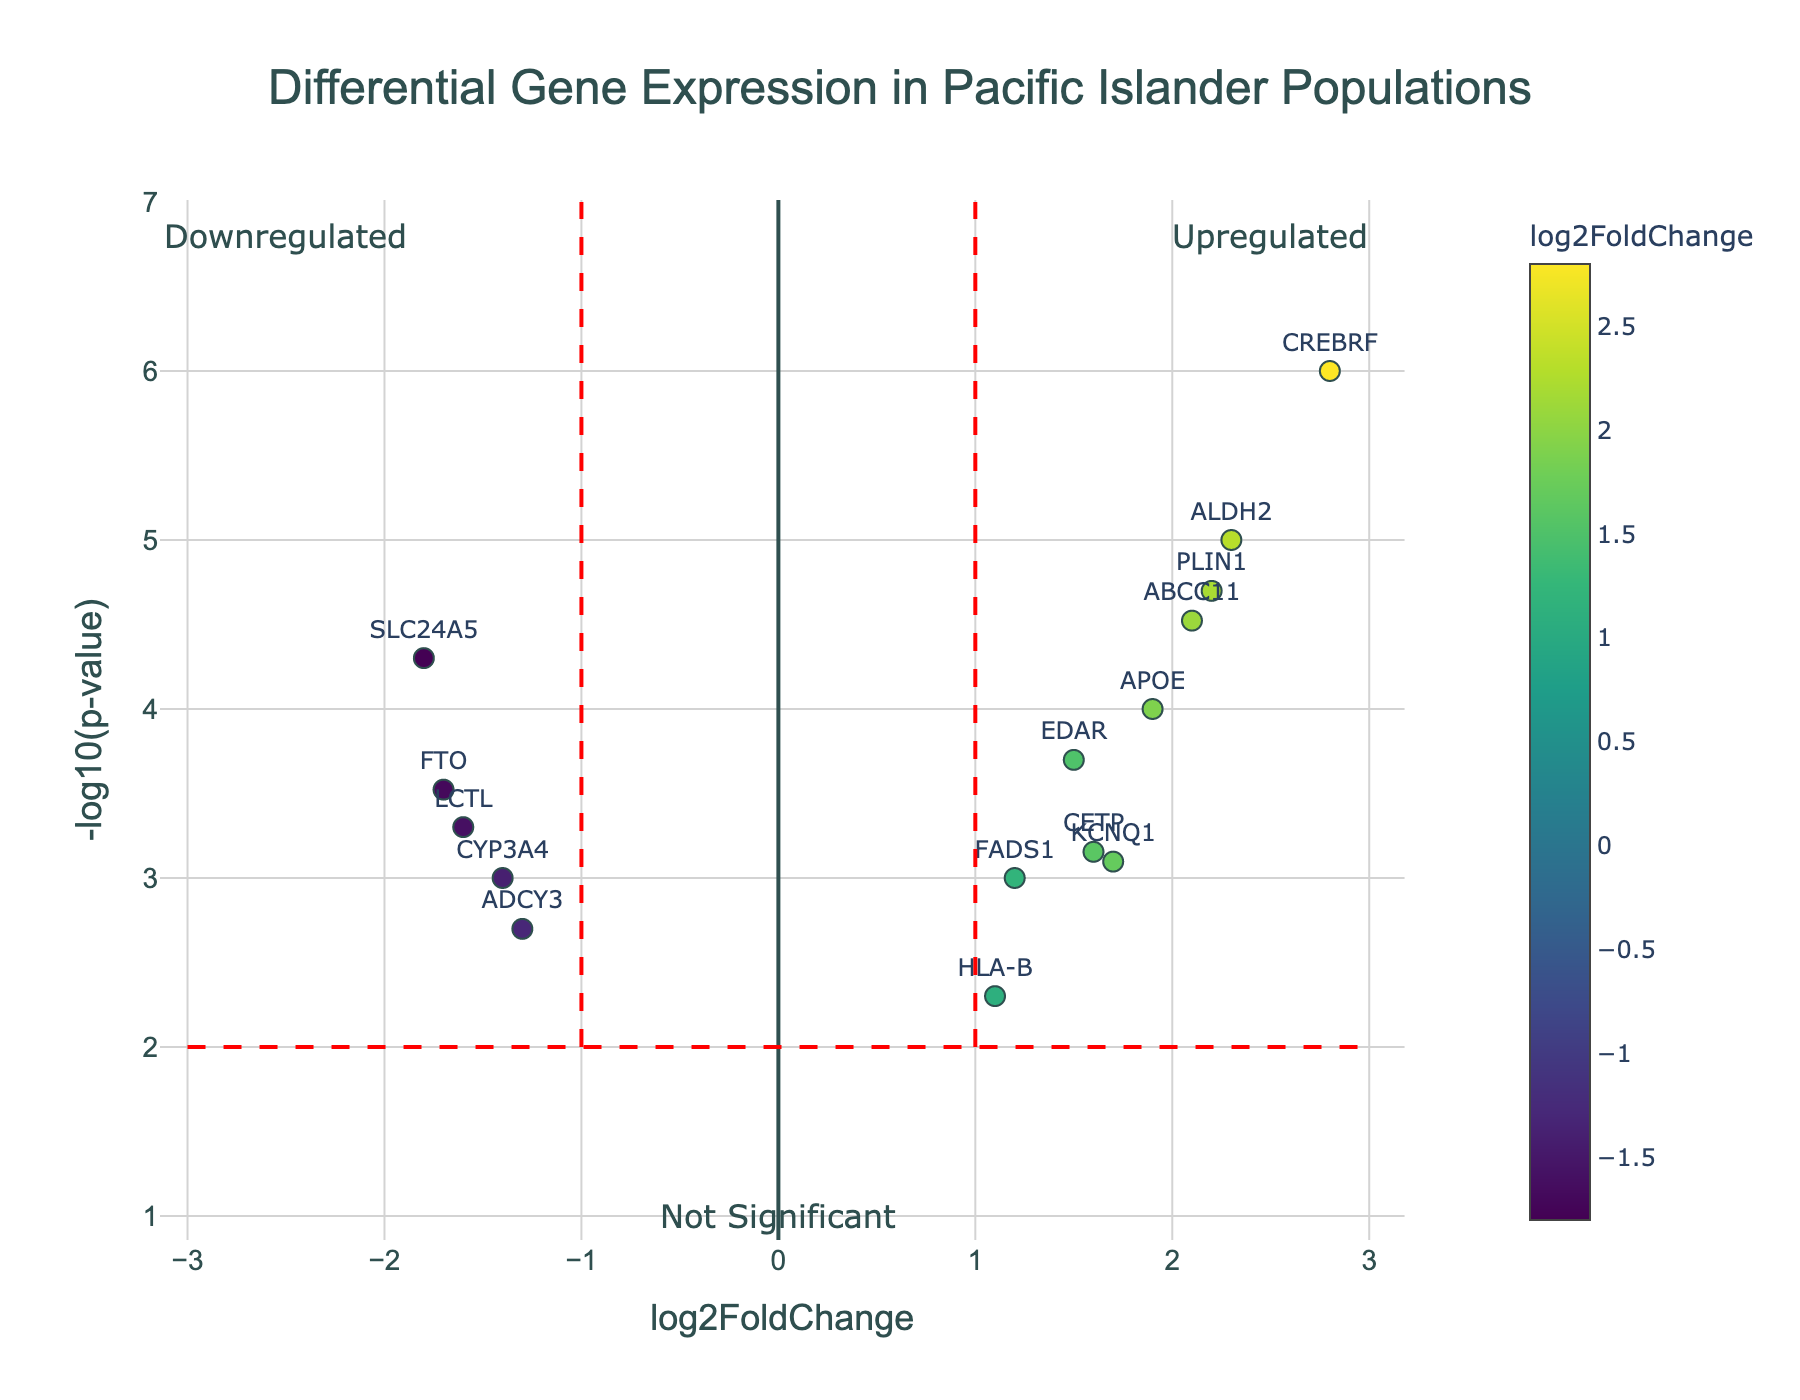what is the color gradient used to indicate in the scatter plot? The color gradient in the scatter plot is used to indicate the log2FoldChange of the genes. Darker colors represent more extreme values, while lighter colors indicate values closer to zero.
Answer: log2FoldChange What does a data point above the horizontal red dashed line represent? Any data point above the horizontal red dashed line represents a gene with a -log10(p-value) greater than 2, indicating it is statistically significant (p-value less than 0.01).
Answer: Statistically significant genes Which gene shows the highest log2FoldChange? By looking at the plot, the gene with the highest log2FoldChange is CREBRF. It is the point farthest to the right, showing a log2FoldChange of 2.8.
Answer: CREBRF What does the left-most red vertical dashed line signify? The left-most red vertical dashed line signifies a log2FoldChange of -1. Genes to the left of this line are considered to have significant downregulation.
Answer: log2FoldChange of -1 How many genes are downregulated significantly? To determine the number of genes downregulated significantly, we count the points to the left of both vertical red dashed lines and above the horizontal dashed line. There are 3 such points.
Answer: 3 genes What does the hover text information provide for each data point? The hover text provides detailed information including the gene name, log2FoldChange value, and p-value for each data point.
Answer: Gene name, log2FoldChange, p-value Between genes APOE and HLA-B, which has a higher log2FoldChange? By comparing the positions of APOE and HLA-B on the x-axis, APOE has a higher log2FoldChange than HLA-B.
Answer: APOE Which region of the plot represents genes that are not significantly differentially expressed? The region of the plot containing genes that are not significantly differentially expressed is below the horizontal red dashed line.
Answer: Below the horizontal red dashed line What can you infer about the upregulated genes in this plot? Upregulated genes are found to the right of the right-most vertical red dashed line and are above the horizontal red dashed line. This indicates these genes have a log2FoldChange greater than 1 and a p-value less than 0.01, meaning they are significantly upregulated.
Answer: Significantly upregulated genes 